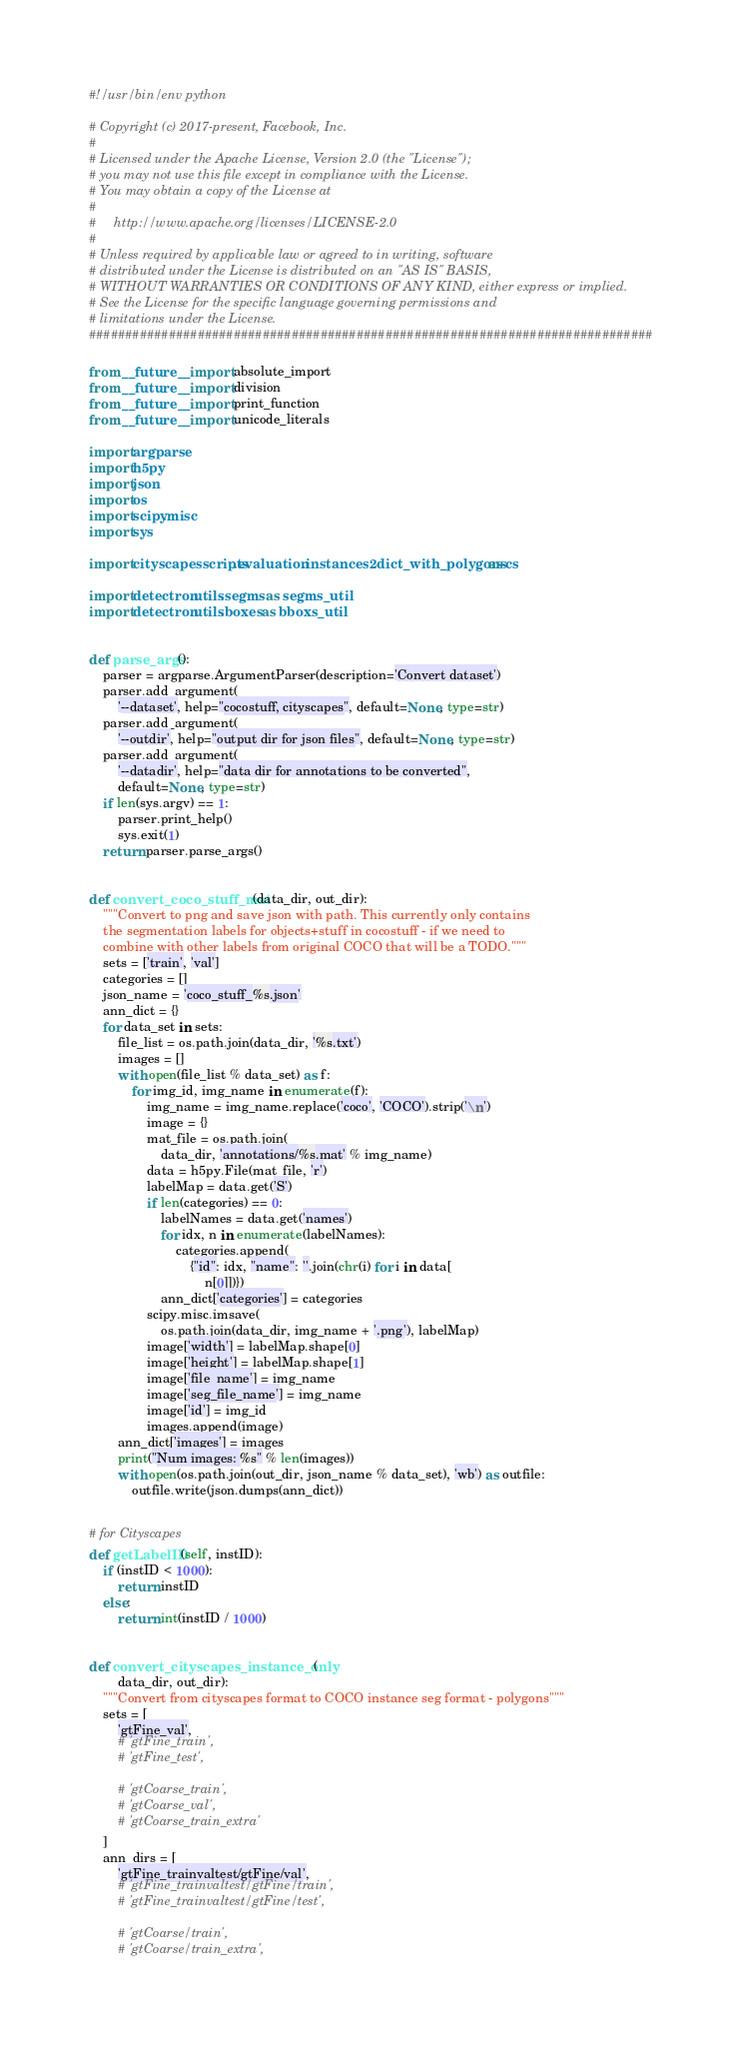<code> <loc_0><loc_0><loc_500><loc_500><_Python_>#!/usr/bin/env python

# Copyright (c) 2017-present, Facebook, Inc.
#
# Licensed under the Apache License, Version 2.0 (the "License");
# you may not use this file except in compliance with the License.
# You may obtain a copy of the License at
#
#     http://www.apache.org/licenses/LICENSE-2.0
#
# Unless required by applicable law or agreed to in writing, software
# distributed under the License is distributed on an "AS IS" BASIS,
# WITHOUT WARRANTIES OR CONDITIONS OF ANY KIND, either express or implied.
# See the License for the specific language governing permissions and
# limitations under the License.
##############################################################################

from __future__ import absolute_import
from __future__ import division
from __future__ import print_function
from __future__ import unicode_literals

import argparse
import h5py
import json
import os
import scipy.misc
import sys

import cityscapesscripts.evaluation.instances2dict_with_polygons as cs

import detectron.utils.segms as segms_util
import detectron.utils.boxes as bboxs_util


def parse_args():
    parser = argparse.ArgumentParser(description='Convert dataset')
    parser.add_argument(
        '--dataset', help="cocostuff, cityscapes", default=None, type=str)
    parser.add_argument(
        '--outdir', help="output dir for json files", default=None, type=str)
    parser.add_argument(
        '--datadir', help="data dir for annotations to be converted",
        default=None, type=str)
    if len(sys.argv) == 1:
        parser.print_help()
        sys.exit(1)
    return parser.parse_args()


def convert_coco_stuff_mat(data_dir, out_dir):
    """Convert to png and save json with path. This currently only contains
    the segmentation labels for objects+stuff in cocostuff - if we need to
    combine with other labels from original COCO that will be a TODO."""
    sets = ['train', 'val']
    categories = []
    json_name = 'coco_stuff_%s.json'
    ann_dict = {}
    for data_set in sets:
        file_list = os.path.join(data_dir, '%s.txt')
        images = []
        with open(file_list % data_set) as f:
            for img_id, img_name in enumerate(f):
                img_name = img_name.replace('coco', 'COCO').strip('\n')
                image = {}
                mat_file = os.path.join(
                    data_dir, 'annotations/%s.mat' % img_name)
                data = h5py.File(mat_file, 'r')
                labelMap = data.get('S')
                if len(categories) == 0:
                    labelNames = data.get('names')
                    for idx, n in enumerate(labelNames):
                        categories.append(
                            {"id": idx, "name": ''.join(chr(i) for i in data[
                                n[0]])})
                    ann_dict['categories'] = categories
                scipy.misc.imsave(
                    os.path.join(data_dir, img_name + '.png'), labelMap)
                image['width'] = labelMap.shape[0]
                image['height'] = labelMap.shape[1]
                image['file_name'] = img_name
                image['seg_file_name'] = img_name
                image['id'] = img_id
                images.append(image)
        ann_dict['images'] = images
        print("Num images: %s" % len(images))
        with open(os.path.join(out_dir, json_name % data_set), 'wb') as outfile:
            outfile.write(json.dumps(ann_dict))


# for Cityscapes
def getLabelID(self, instID):
    if (instID < 1000):
        return instID
    else:
        return int(instID / 1000)


def convert_cityscapes_instance_only(
        data_dir, out_dir):
    """Convert from cityscapes format to COCO instance seg format - polygons"""
    sets = [
        'gtFine_val',
        # 'gtFine_train',
        # 'gtFine_test',

        # 'gtCoarse_train',
        # 'gtCoarse_val',
        # 'gtCoarse_train_extra'
    ]
    ann_dirs = [
        'gtFine_trainvaltest/gtFine/val',
        # 'gtFine_trainvaltest/gtFine/train',
        # 'gtFine_trainvaltest/gtFine/test',

        # 'gtCoarse/train',
        # 'gtCoarse/train_extra',</code> 